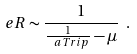<formula> <loc_0><loc_0><loc_500><loc_500>\ e R \sim \frac { 1 } { \frac { 1 } { \ a T r i p } - \mu } \ .</formula> 